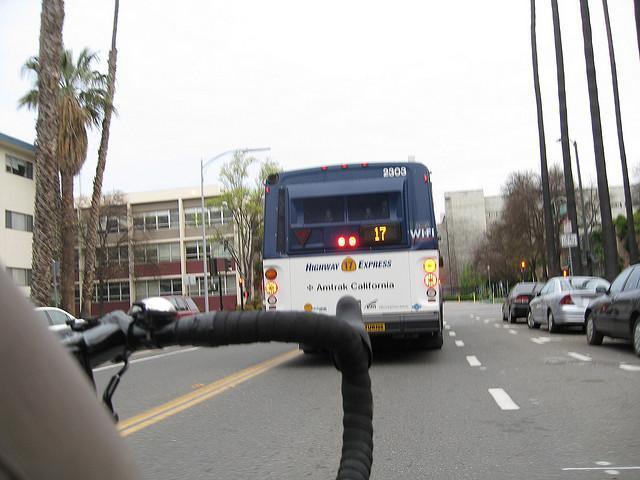How many cars are parked on the right side of the road?
Give a very brief answer. 3. How many stories are in the building with red?
Give a very brief answer. 3. How many cars are there?
Give a very brief answer. 2. 